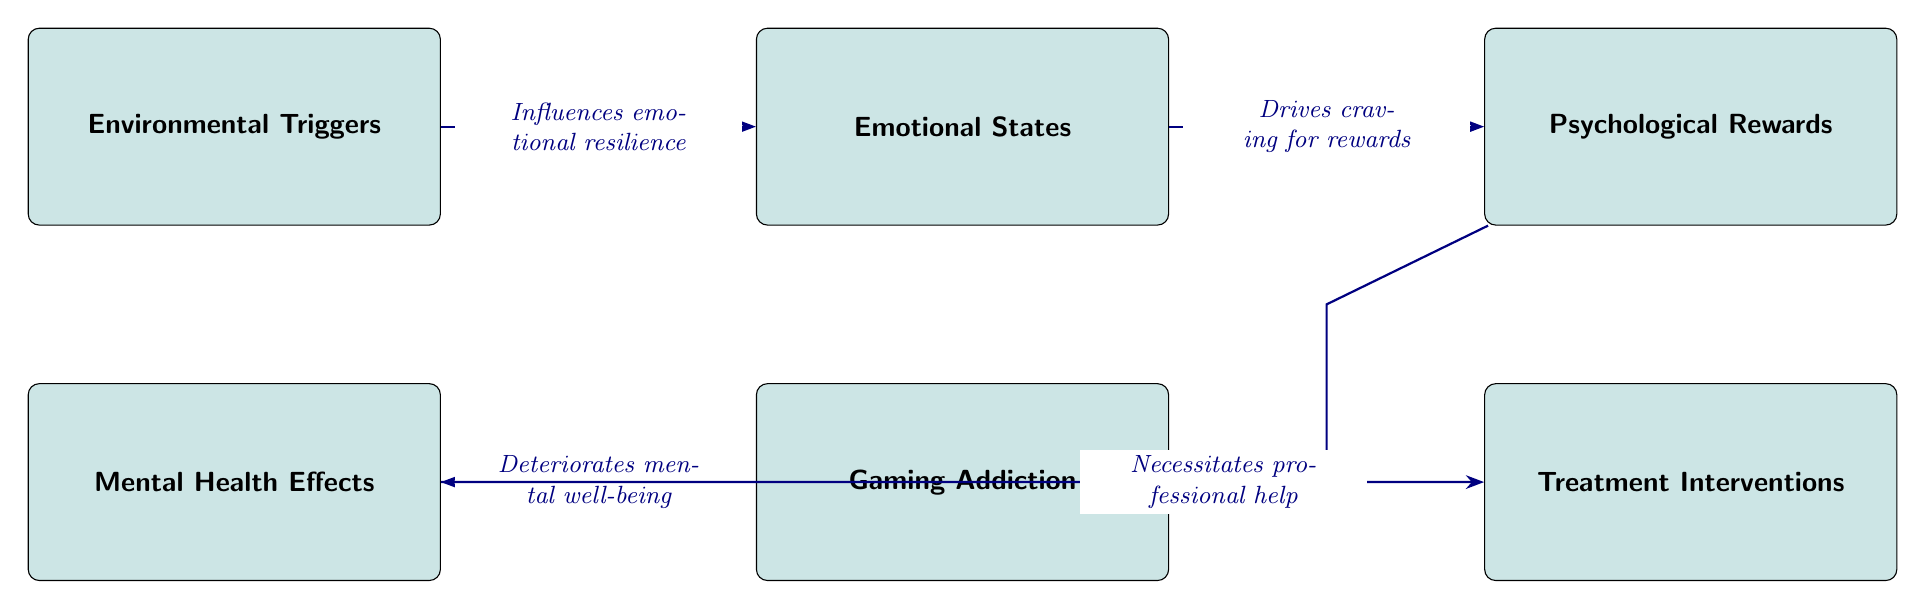What is the first node in the diagram? The first node in the diagram is "Environmental Triggers," which is the leftmost block representing initial factors that influence the progression through the diagram.
Answer: Environmental Triggers How many blocks are in the diagram? The diagram contains five blocks representing various concepts related to gaming addiction and mental well-being, specifically: Environmental Triggers, Emotional States, Psychological Rewards, Gaming Addiction, and Mental Health Effects.
Answer: 5 What does "Gaming Addiction" lead to? According to the diagram, "Gaming Addiction" leads to "Mental Health Effects," indicating a negative correlation between addiction and mental well-being.
Answer: Mental Health Effects What is the relationship between "Emotional States" and "Psychological Rewards"? The diagram shows that "Emotional States" drives the craving for "Psychological Rewards," indicating that emotional factors are linked to the desire for rewarding experiences.
Answer: Drives craving for rewards What happens after "Mental Health Effects"? The diagram indicates that "Mental Health Effects" necessitates "Treatment Interventions," suggesting that negative impacts on mental health require professional assistance.
Answer: Treatment Interventions What influences emotional resilience? The diagram demonstrates that "Environmental Triggers" influence "Emotional States," showing that the initial environment plays a role in how well one can cope emotionally.
Answer: Influences emotional resilience How does "Psychological Rewards" relate to "Gaming Addiction"? According to the diagram, "Psychological Rewards" reinforces addictive behavior in "Gaming Addiction," implying that the desire for these rewards perpetuates the addiction cycle.
Answer: Reinforces addictive behavior What type of intervention is required as a result of "Mental Health Effects"? The diagram states that "Mental Health Effects" necessitates "Treatment Interventions," indicating a need for professional help when mental well-being is compromised.
Answer: Professional help 